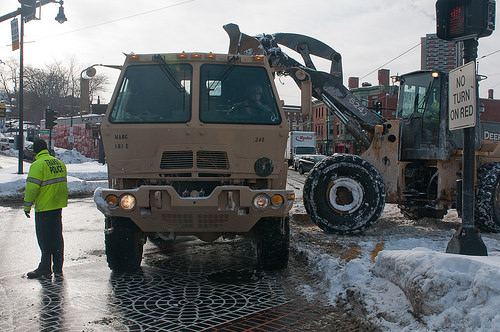<image>
Is there a van behind the man? No. The van is not behind the man. From this viewpoint, the van appears to be positioned elsewhere in the scene. 